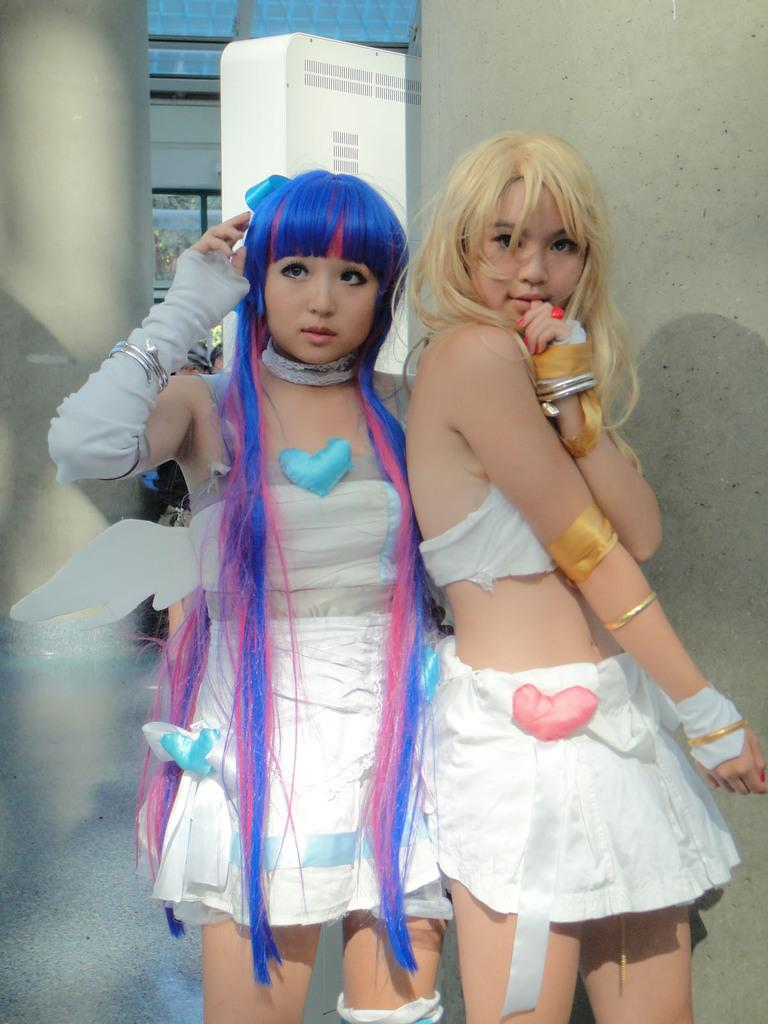How many people are in the image? There are two girls in the image. What are the girls wearing? The girls are wearing white dresses. What are the girls doing in the image? The girls are standing and posing. What color is the wall in the background of the image? The wall in the background of the image is grey. What type of crack can be seen on the wall in the image? There is no crack visible on the wall in the image; it is a smooth grey color. How does the mind of the girls affect the image? The image does not provide any information about the girls' minds or thoughts, so we cannot determine how their minds might affect the image. 